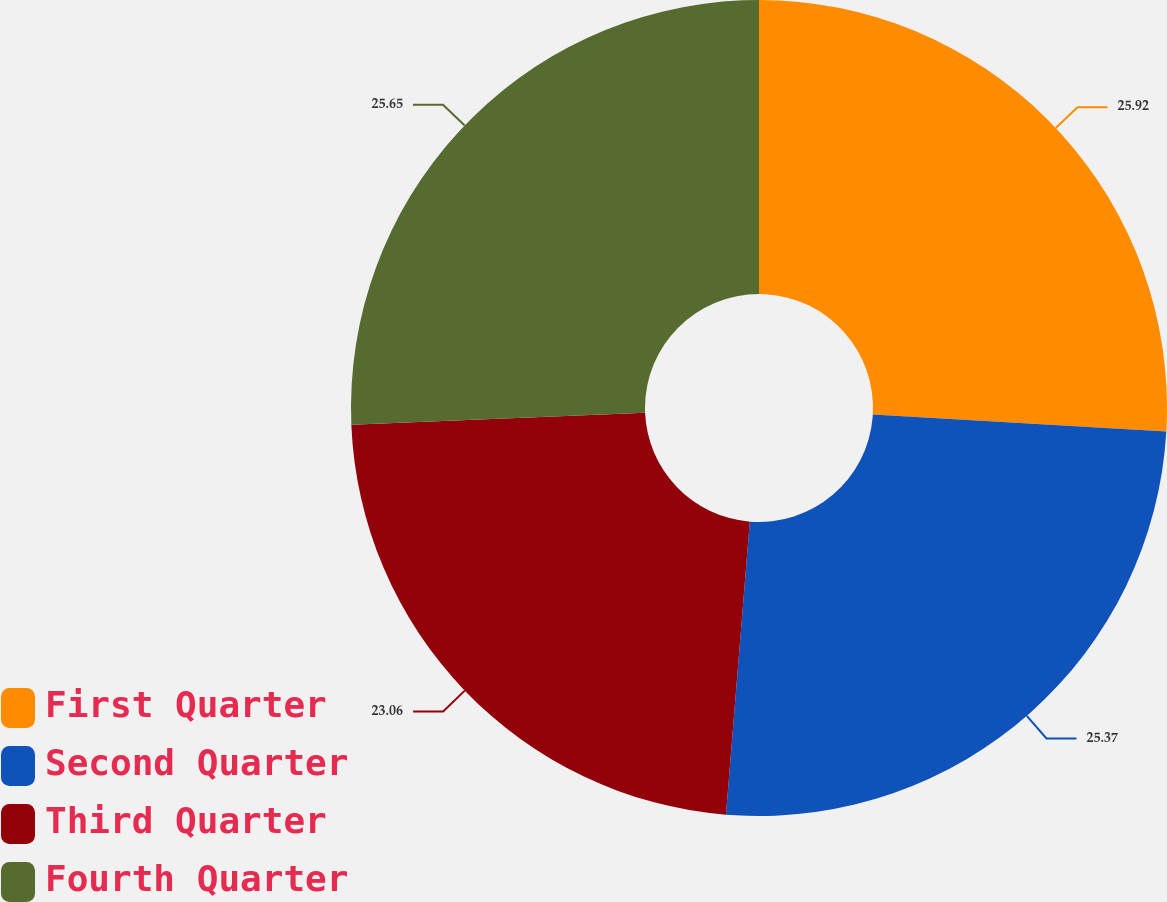Convert chart to OTSL. <chart><loc_0><loc_0><loc_500><loc_500><pie_chart><fcel>First Quarter<fcel>Second Quarter<fcel>Third Quarter<fcel>Fourth Quarter<nl><fcel>25.92%<fcel>25.37%<fcel>23.06%<fcel>25.65%<nl></chart> 